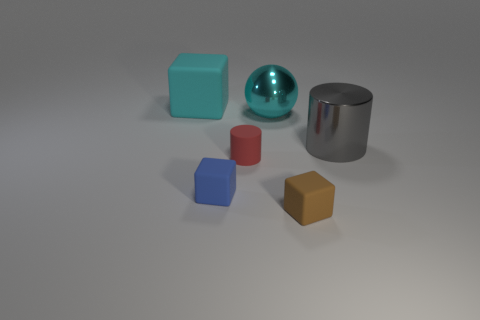Are there any gray things of the same size as the gray cylinder?
Make the answer very short. No. There is a big thing that is on the right side of the cyan ball; what is its material?
Offer a very short reply. Metal. Are there an equal number of metallic cylinders in front of the small red matte cylinder and large gray cylinders that are left of the big metallic cylinder?
Provide a succinct answer. Yes. There is a matte cube behind the small cylinder; does it have the same size as the brown cube in front of the small matte cylinder?
Ensure brevity in your answer.  No. What number of balls are the same color as the large rubber thing?
Give a very brief answer. 1. What is the material of the thing that is the same color as the large ball?
Offer a terse response. Rubber. Are there more tiny blocks in front of the small blue object than brown metal objects?
Give a very brief answer. Yes. Do the large cyan metal object and the red thing have the same shape?
Your answer should be compact. No. What number of large gray objects are the same material as the small blue thing?
Provide a short and direct response. 0. There is a cyan object that is the same shape as the blue rubber thing; what size is it?
Your answer should be compact. Large. 